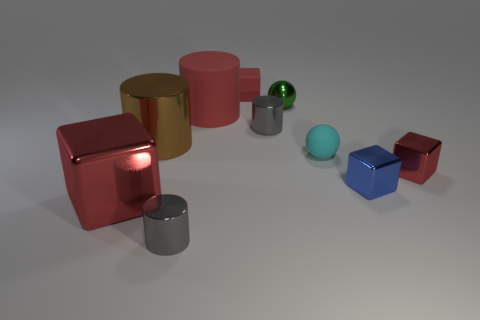Subtract all red blocks. How many were subtracted if there are1red blocks left? 2 Subtract all red cubes. How many cubes are left? 1 Subtract all blue blocks. How many blocks are left? 3 Subtract 2 cylinders. How many cylinders are left? 2 Subtract all cubes. How many objects are left? 6 Subtract all blue cubes. Subtract all yellow spheres. How many cubes are left? 3 Subtract all blue balls. How many gray cylinders are left? 2 Subtract all green metal spheres. Subtract all tiny things. How many objects are left? 2 Add 1 blue metal cubes. How many blue metal cubes are left? 2 Add 3 rubber cylinders. How many rubber cylinders exist? 4 